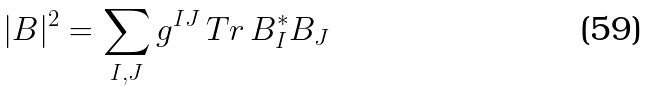<formula> <loc_0><loc_0><loc_500><loc_500>| B | ^ { 2 } = \sum _ { I , J } g ^ { I J } \, T r \, B _ { I } ^ { * } B _ { J }</formula> 